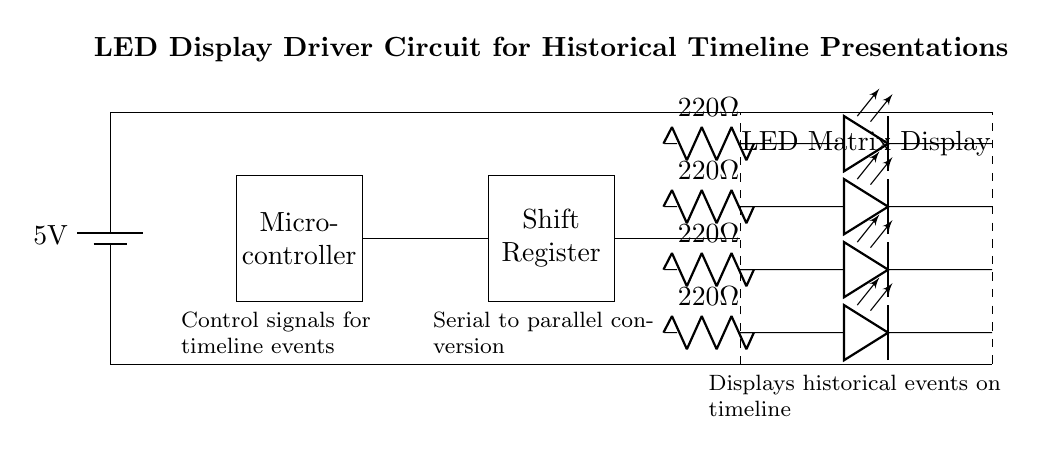What component provides the control signals for the timeline events? The control signals for the timeline events are generated by the microcontroller, which is positioned on the left side of the circuit.
Answer: Microcontroller What is the resistance value of the current limiting resistors? The circuit shows that each current limiting resistor is labeled as two hundred twenty ohms, indicating their resistance.
Answer: 220 ohm How many LEDs are in the LED matrix display section? The circuit shows four rows of LEDs connected in parallel between the matrix and the driver, which indicates there are four LEDs.
Answer: Four What type of conversion does the shift register perform? The shift register converts serial data from the microcontroller into parallel signals to drive the LED matrix display, which is indicated in the accompanying labels of the diagram.
Answer: Serial to parallel What voltage is supplied to the circuit? The voltage in the circuit is supplied by a battery, which is labeled as five volts, indicating the power source's potential difference.
Answer: 5 volts How is power distributed across the circuit? Power is distributed across the circuit using a direct connection from the battery to both the LED matrix and microcontroller, visible from the top horizontal lines connecting components.
Answer: Direct connection 